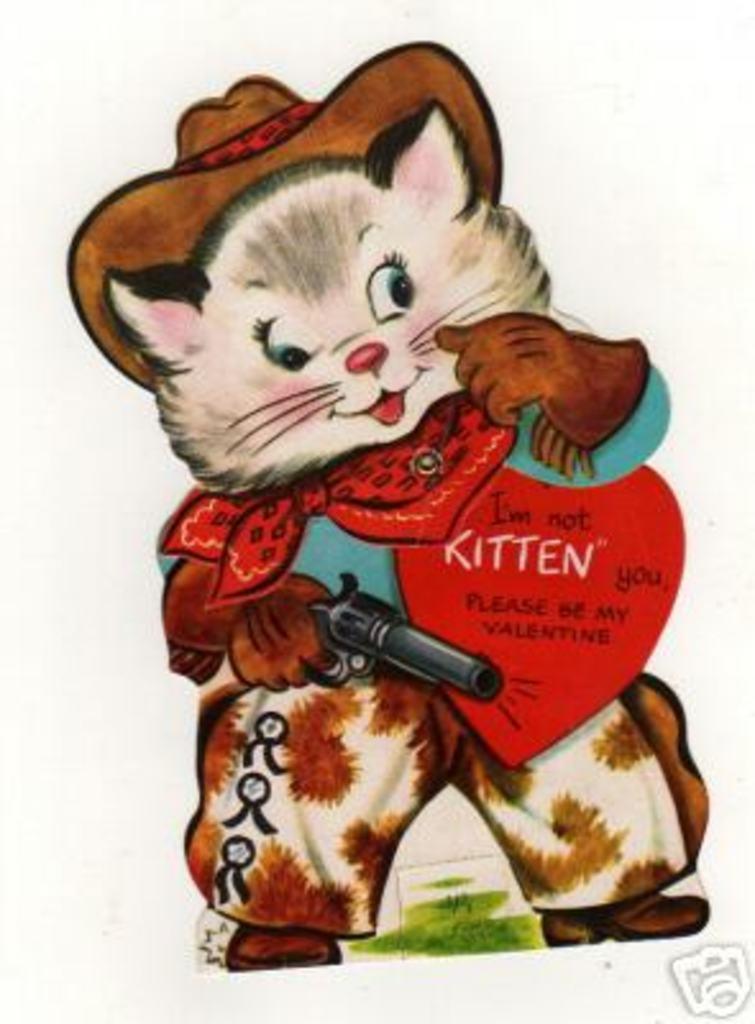Please provide a concise description of this image. In the picture we can see some cartoon character holding a gun. 